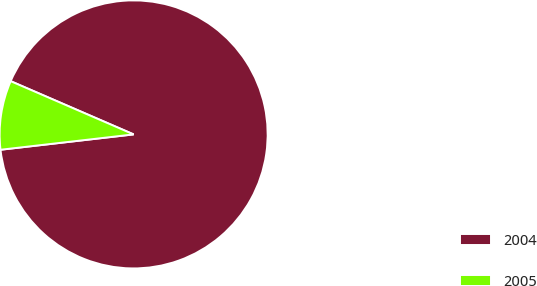<chart> <loc_0><loc_0><loc_500><loc_500><pie_chart><fcel>2004<fcel>2005<nl><fcel>91.67%<fcel>8.33%<nl></chart> 